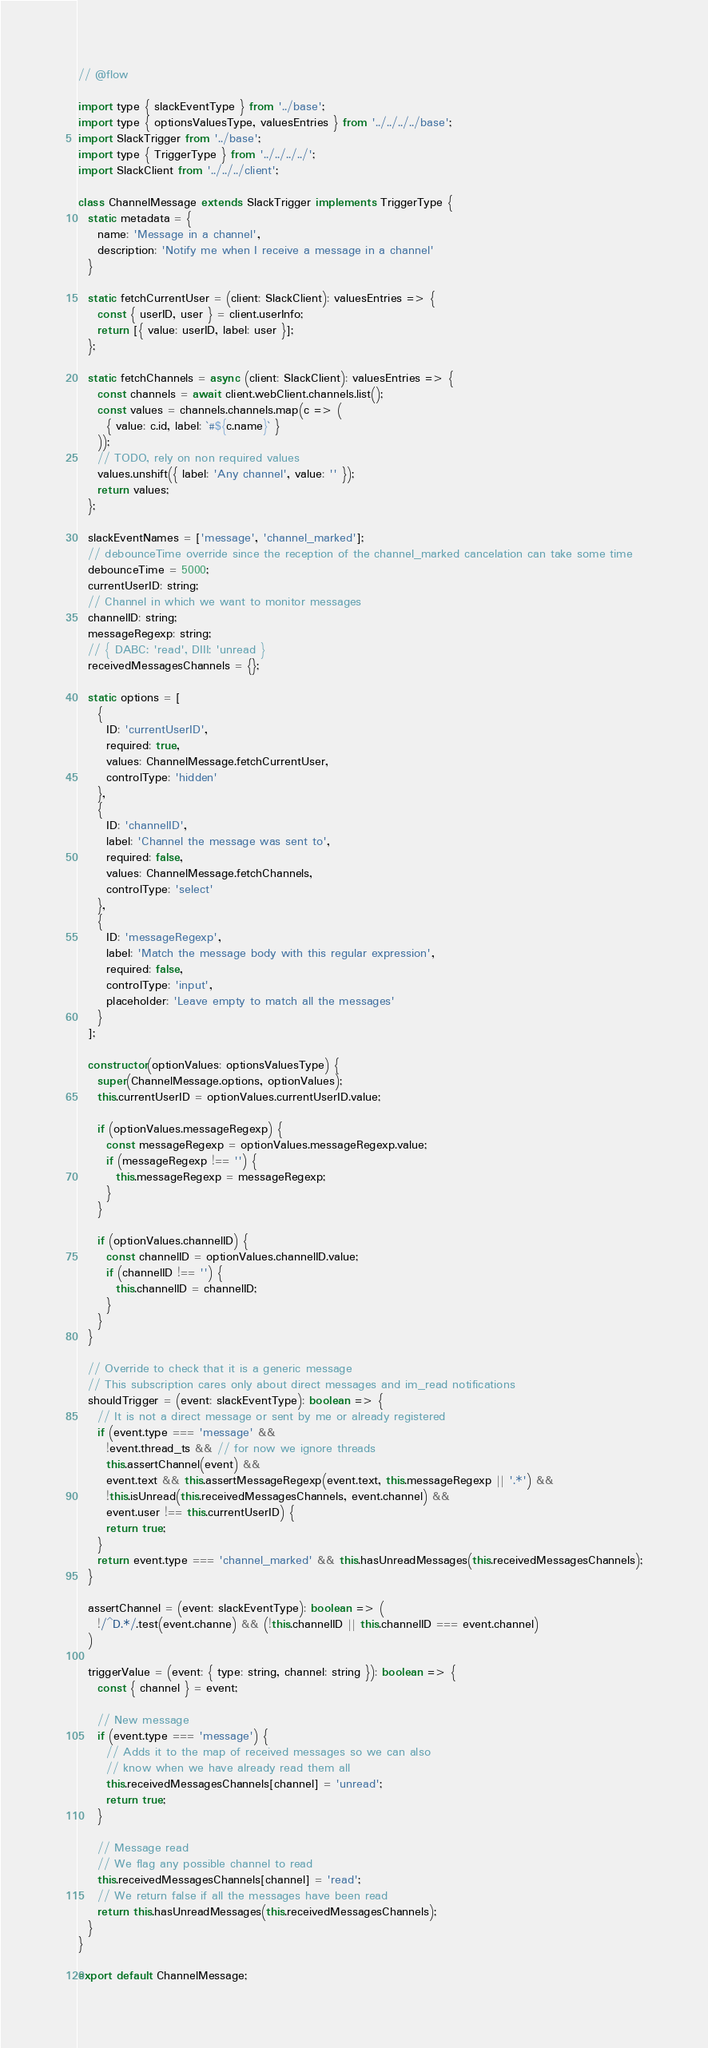Convert code to text. <code><loc_0><loc_0><loc_500><loc_500><_JavaScript_>// @flow

import type { slackEventType } from '../base';
import type { optionsValuesType, valuesEntries } from '../../../../base';
import SlackTrigger from '../base';
import type { TriggerType } from '../../../../';
import SlackClient from '../../../client';

class ChannelMessage extends SlackTrigger implements TriggerType {
  static metadata = {
    name: 'Message in a channel',
    description: 'Notify me when I receive a message in a channel'
  }

  static fetchCurrentUser = (client: SlackClient): valuesEntries => {
    const { userID, user } = client.userInfo;
    return [{ value: userID, label: user }];
  };

  static fetchChannels = async (client: SlackClient): valuesEntries => {
    const channels = await client.webClient.channels.list();
    const values = channels.channels.map(c => (
      { value: c.id, label: `#${c.name}` }
    ));
    // TODO, rely on non required values
    values.unshift({ label: 'Any channel', value: '' });
    return values;
  };

  slackEventNames = ['message', 'channel_marked'];
  // debounceTime override since the reception of the channel_marked cancelation can take some time
  debounceTime = 5000;
  currentUserID: string;
  // Channel in which we want to monitor messages
  channelID: string;
  messageRegexp: string;
  // { DABC: 'read', DIII: 'unread }
  receivedMessagesChannels = {};

  static options = [
    {
      ID: 'currentUserID',
      required: true,
      values: ChannelMessage.fetchCurrentUser,
      controlType: 'hidden'
    },
    {
      ID: 'channelID',
      label: 'Channel the message was sent to',
      required: false,
      values: ChannelMessage.fetchChannels,
      controlType: 'select'
    },
    {
      ID: 'messageRegexp',
      label: 'Match the message body with this regular expression',
      required: false,
      controlType: 'input',
      placeholder: 'Leave empty to match all the messages'
    }
  ];

  constructor(optionValues: optionsValuesType) {
    super(ChannelMessage.options, optionValues);
    this.currentUserID = optionValues.currentUserID.value;

    if (optionValues.messageRegexp) {
      const messageRegexp = optionValues.messageRegexp.value;
      if (messageRegexp !== '') {
        this.messageRegexp = messageRegexp;
      }
    }

    if (optionValues.channelID) {
      const channelID = optionValues.channelID.value;
      if (channelID !== '') {
        this.channelID = channelID;
      }
    }
  }

  // Override to check that it is a generic message
  // This subscription cares only about direct messages and im_read notifications
  shouldTrigger = (event: slackEventType): boolean => {
    // It is not a direct message or sent by me or already registered
    if (event.type === 'message' &&
      !event.thread_ts && // for now we ignore threads
      this.assertChannel(event) &&
      event.text && this.assertMessageRegexp(event.text, this.messageRegexp || '.*') &&
      !this.isUnread(this.receivedMessagesChannels, event.channel) &&
      event.user !== this.currentUserID) {
      return true;
    }
    return event.type === 'channel_marked' && this.hasUnreadMessages(this.receivedMessagesChannels);
  }

  assertChannel = (event: slackEventType): boolean => (
    !/^D.*/.test(event.channe) && (!this.channelID || this.channelID === event.channel)
  )

  triggerValue = (event: { type: string, channel: string }): boolean => {
    const { channel } = event;

    // New message
    if (event.type === 'message') {
      // Adds it to the map of received messages so we can also
      // know when we have already read them all
      this.receivedMessagesChannels[channel] = 'unread';
      return true;
    }

    // Message read
    // We flag any possible channel to read
    this.receivedMessagesChannels[channel] = 'read';
    // We return false if all the messages have been read
    return this.hasUnreadMessages(this.receivedMessagesChannels);
  }
}

export default ChannelMessage;
</code> 